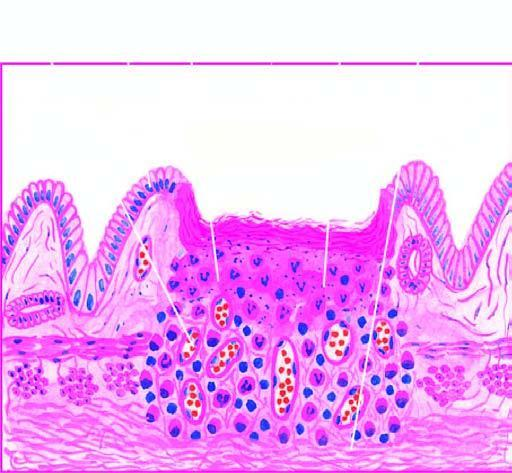does the epidermis show necrotic debris, ulceration and inflammation on the mucosal surface?
Answer the question using a single word or phrase. No 